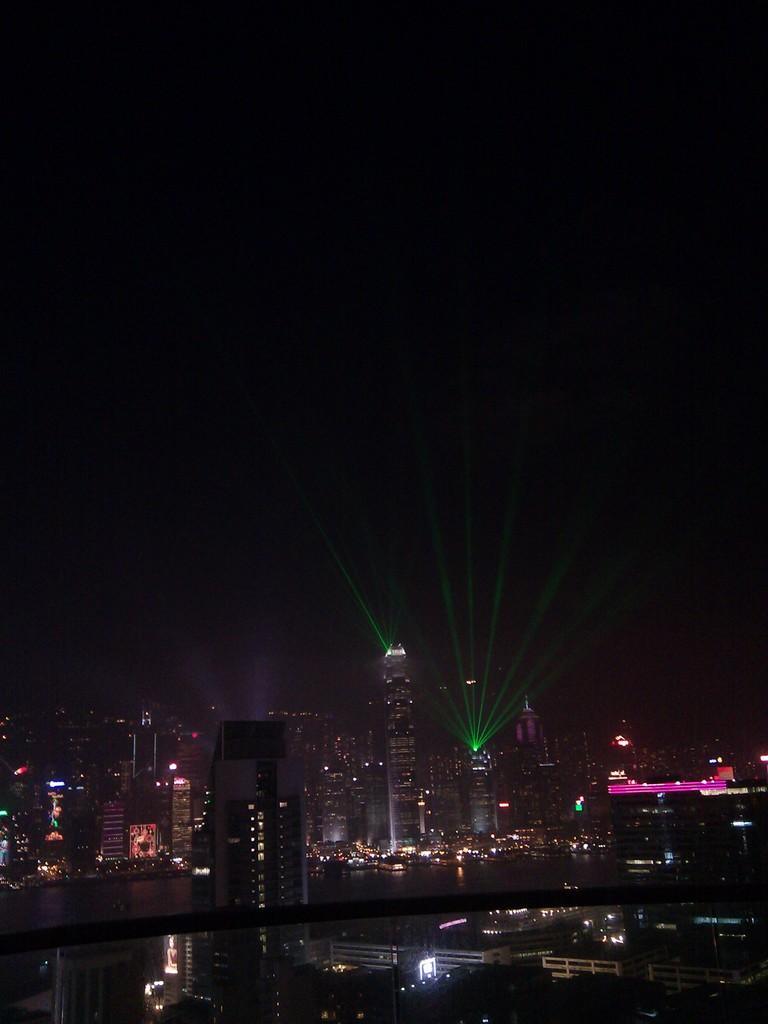What type of structures are visible in the image? There are buildings with lights in the image. What can be observed about the background of the image? The background of the image is dark. What advice does the potato give to the buildings in the image? There is no potato present in the image, and therefore no advice can be given. 